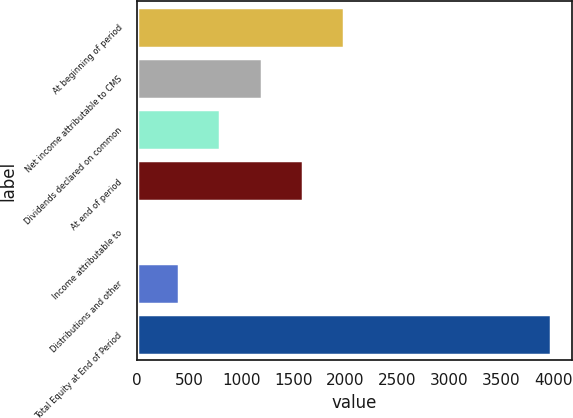Convert chart. <chart><loc_0><loc_0><loc_500><loc_500><bar_chart><fcel>At beginning of period<fcel>Net income attributable to CMS<fcel>Dividends declared on common<fcel>At end of period<fcel>Income attributable to<fcel>Distributions and other<fcel>Total Equity at End of Period<nl><fcel>1988.5<fcel>1193.9<fcel>796.6<fcel>1591.2<fcel>2<fcel>399.3<fcel>3975<nl></chart> 